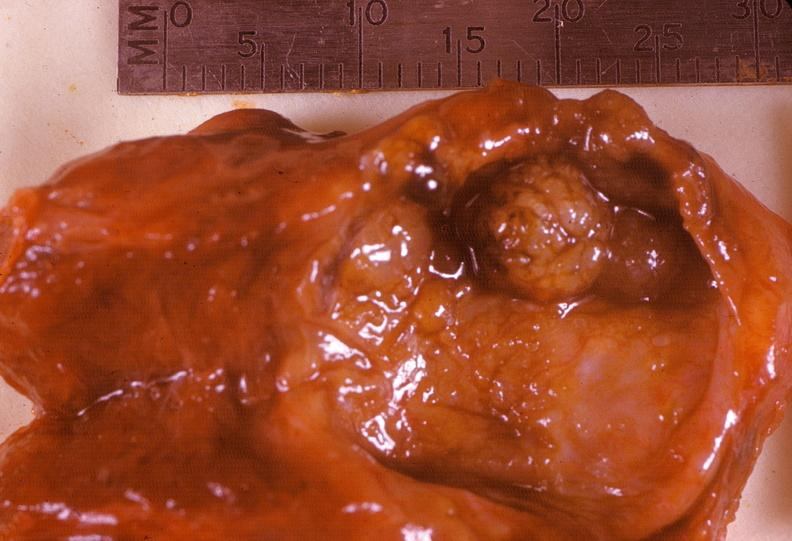what does this image show?
Answer the question using a single word or phrase. Thyroid 